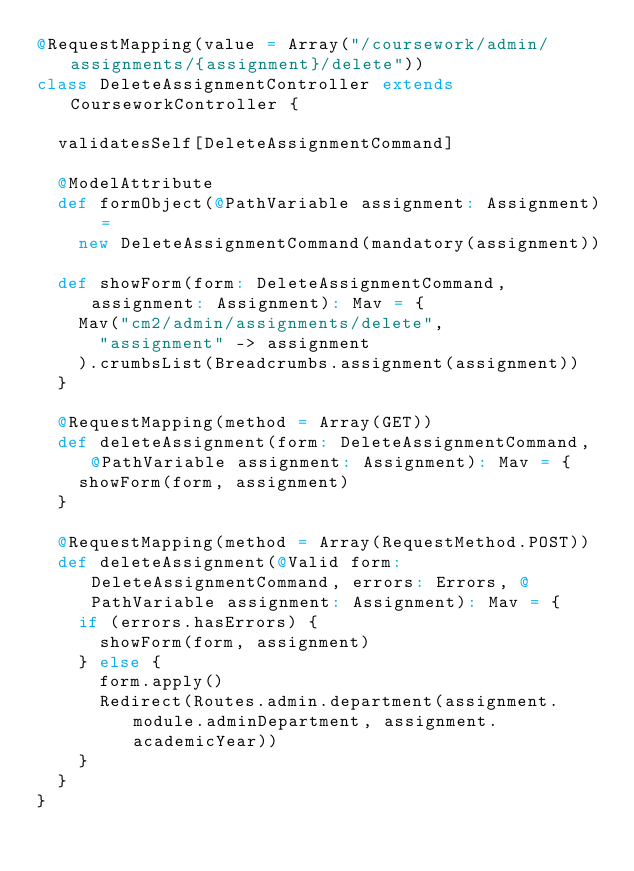Convert code to text. <code><loc_0><loc_0><loc_500><loc_500><_Scala_>@RequestMapping(value = Array("/coursework/admin/assignments/{assignment}/delete"))
class DeleteAssignmentController extends CourseworkController {

  validatesSelf[DeleteAssignmentCommand]

  @ModelAttribute
  def formObject(@PathVariable assignment: Assignment) =
    new DeleteAssignmentCommand(mandatory(assignment))

  def showForm(form: DeleteAssignmentCommand, assignment: Assignment): Mav = {
    Mav("cm2/admin/assignments/delete",
      "assignment" -> assignment
    ).crumbsList(Breadcrumbs.assignment(assignment))
  }

  @RequestMapping(method = Array(GET))
  def deleteAssignment(form: DeleteAssignmentCommand, @PathVariable assignment: Assignment): Mav = {
    showForm(form, assignment)
  }

  @RequestMapping(method = Array(RequestMethod.POST))
  def deleteAssignment(@Valid form: DeleteAssignmentCommand, errors: Errors, @PathVariable assignment: Assignment): Mav = {
    if (errors.hasErrors) {
      showForm(form, assignment)
    } else {
      form.apply()
      Redirect(Routes.admin.department(assignment.module.adminDepartment, assignment.academicYear))
    }
  }
}
</code> 